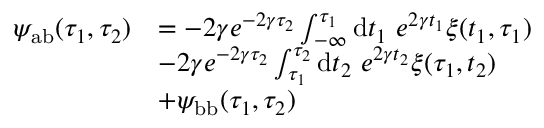Convert formula to latex. <formula><loc_0><loc_0><loc_500><loc_500>\begin{array} { r l } { \psi _ { a b } ( \tau _ { 1 } , \tau _ { 2 } ) } & { = - 2 \gamma e ^ { - 2 \gamma \tau _ { 2 } } \int _ { - \infty } ^ { \tau _ { 1 } } d t _ { 1 } e ^ { 2 \gamma t _ { 1 } } \xi ( t _ { 1 } , \tau _ { 1 } ) } \\ & { - 2 \gamma e ^ { - 2 \gamma \tau _ { 2 } } \int _ { \tau _ { 1 } } ^ { \tau _ { 2 } } d t _ { 2 } e ^ { 2 \gamma t _ { 2 } } \xi ( \tau _ { 1 } , t _ { 2 } ) } \\ & { + \psi _ { b b } ( \tau _ { 1 } , \tau _ { 2 } ) } \end{array}</formula> 